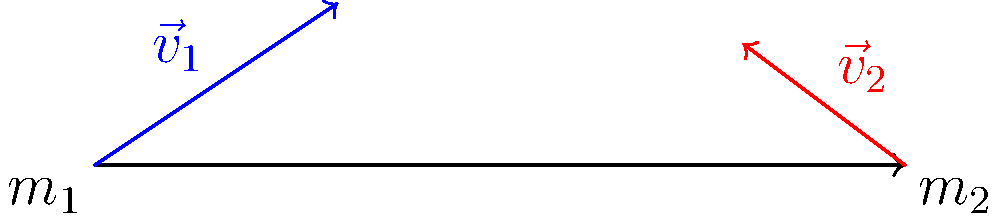During a soccer match, two players collide while going for the ball. Player 1, with mass $m_1 = 70$ kg, is running with velocity $\vec{v}_1 = 4\hat{i} + 3\hat{j}$ m/s. Player 2, with mass $m_2 = 80$ kg, is running with velocity $\vec{v}_2 = -3\hat{i} + 2\hat{j}$ m/s. Assuming a perfectly inelastic collision, what is the velocity of the players immediately after the collision? Let's approach this step-by-step:

1) In a perfectly inelastic collision, the two objects stick together after the collision and move with the same final velocity $\vec{v}_f$.

2) We can use the conservation of momentum principle:
   $$(m_1\vec{v}_1 + m_2\vec{v}_2 = (m_1 + m_2)\vec{v}_f$$

3) Let's calculate the total momentum before the collision:
   $\vec{p}_i = m_1\vec{v}_1 + m_2\vec{v}_2$
   $= 70(4\hat{i} + 3\hat{j}) + 80(-3\hat{i} + 2\hat{j})$
   $= (280\hat{i} + 210\hat{j}) + (-240\hat{i} + 160\hat{j})$
   $= 40\hat{i} + 370\hat{j}$

4) The total mass after the collision is:
   $m_{total} = m_1 + m_2 = 70 + 80 = 150$ kg

5) Now we can find $\vec{v}_f$:
   $\vec{v}_f = \frac{\vec{p}_i}{m_{total}} = \frac{40\hat{i} + 370\hat{j}}{150}$

6) Simplifying:
   $\vec{v}_f = \frac{4}{15}\hat{i} + \frac{37}{15}\hat{j}$

7) Converting to decimal form:
   $\vec{v}_f \approx 0.27\hat{i} + 2.47\hat{j}$ m/s
Answer: $\vec{v}_f = 0.27\hat{i} + 2.47\hat{j}$ m/s 